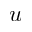Convert formula to latex. <formula><loc_0><loc_0><loc_500><loc_500>u</formula> 